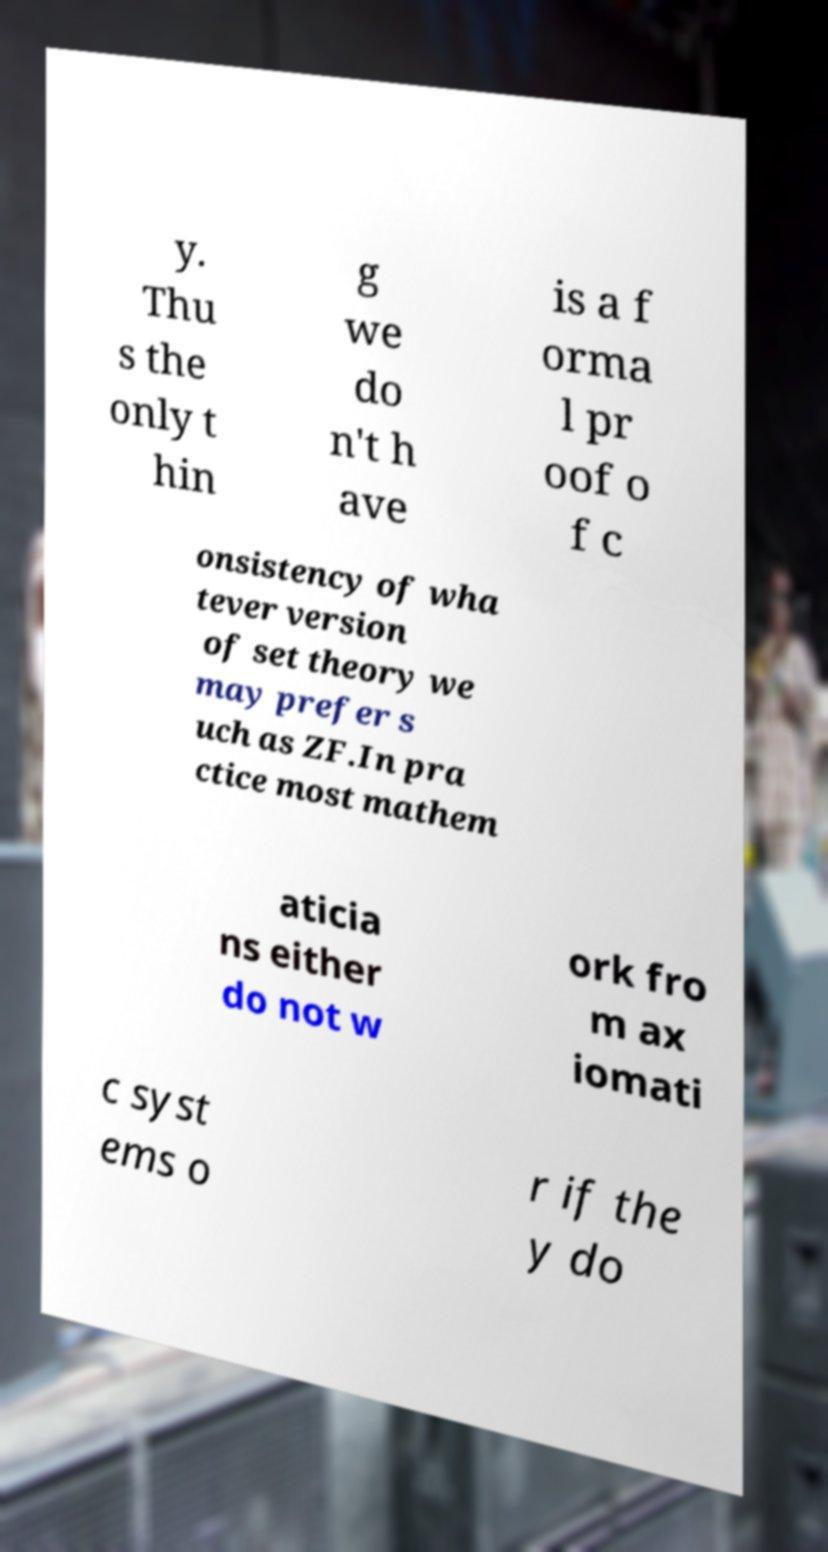Can you read and provide the text displayed in the image?This photo seems to have some interesting text. Can you extract and type it out for me? y. Thu s the only t hin g we do n't h ave is a f orma l pr oof o f c onsistency of wha tever version of set theory we may prefer s uch as ZF.In pra ctice most mathem aticia ns either do not w ork fro m ax iomati c syst ems o r if the y do 